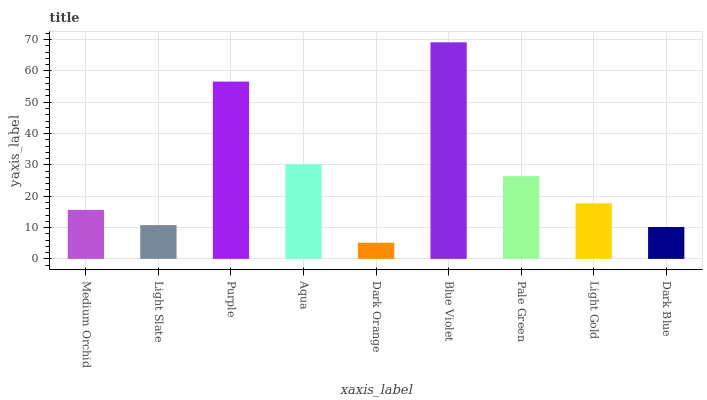Is Light Slate the minimum?
Answer yes or no. No. Is Light Slate the maximum?
Answer yes or no. No. Is Medium Orchid greater than Light Slate?
Answer yes or no. Yes. Is Light Slate less than Medium Orchid?
Answer yes or no. Yes. Is Light Slate greater than Medium Orchid?
Answer yes or no. No. Is Medium Orchid less than Light Slate?
Answer yes or no. No. Is Light Gold the high median?
Answer yes or no. Yes. Is Light Gold the low median?
Answer yes or no. Yes. Is Aqua the high median?
Answer yes or no. No. Is Dark Orange the low median?
Answer yes or no. No. 